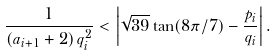<formula> <loc_0><loc_0><loc_500><loc_500>\frac { 1 } { \left ( a _ { i + 1 } + 2 \right ) q _ { i } ^ { 2 } } < \left | \sqrt { 3 9 } \tan ( 8 \pi / 7 ) - \frac { p _ { i } } { q _ { i } } \right | .</formula> 